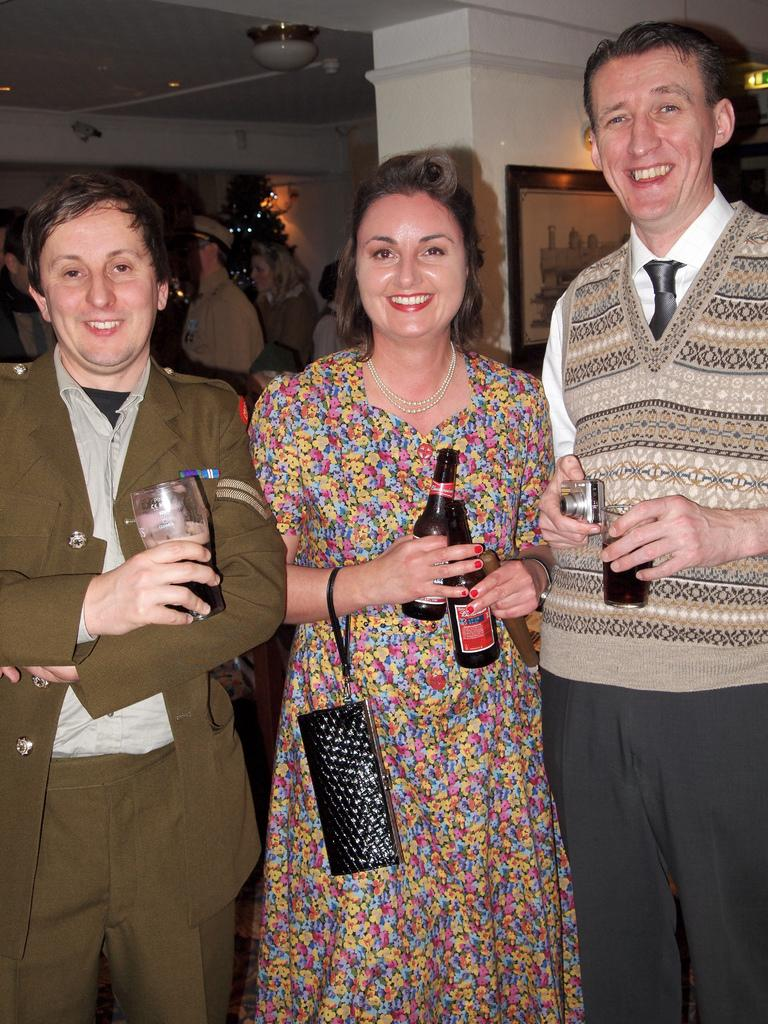Who is the main subject in the image? There is a woman in the image. What is the woman's position in relation to the men? The woman is standing between two men. What are the men holding in the image? The men are holding bottles and one man is holding wine glasses. Can you describe the background of the image? There are other people visible in the background. What is present on the wall in the image? There is a photo frame on the wall. What type of water can be seen flowing through the bushes in the image? There is no water or bushes present in the image. 